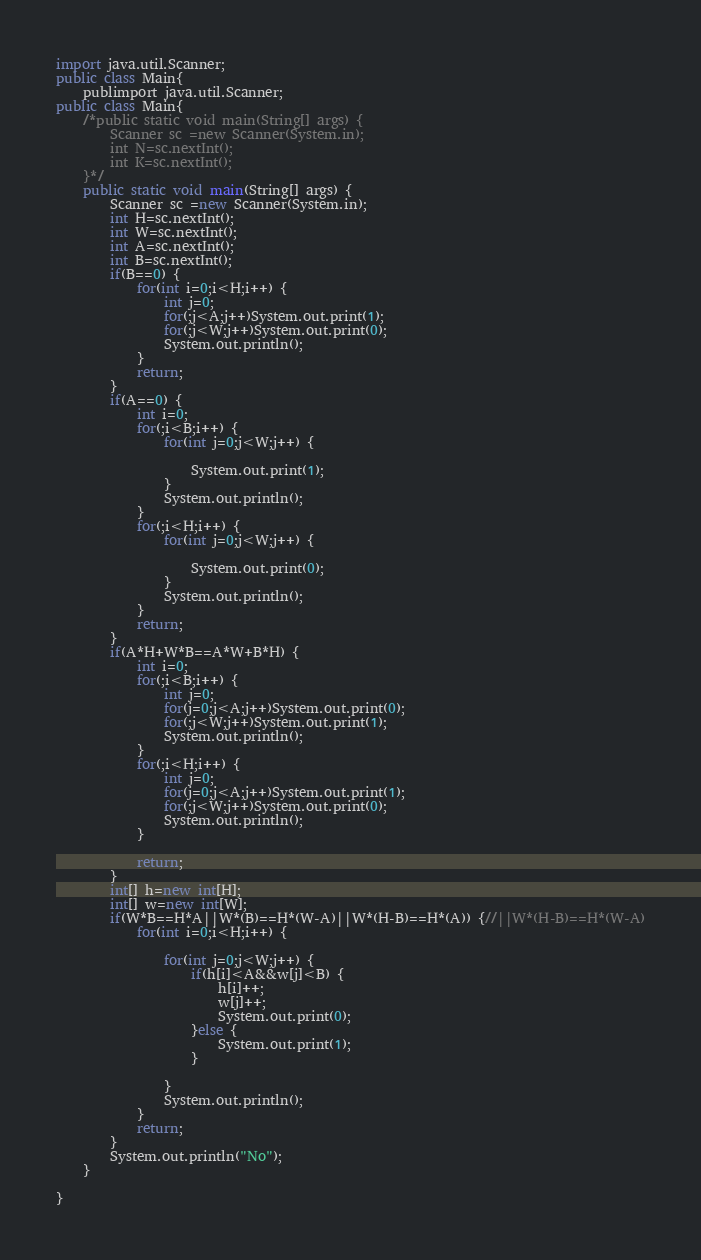Convert code to text. <code><loc_0><loc_0><loc_500><loc_500><_Java_>import java.util.Scanner;
public class Main{
	publimport java.util.Scanner;
public class Main{
	/*public static void main(String[] args) {
		Scanner sc =new Scanner(System.in);
		int N=sc.nextInt();
		int K=sc.nextInt();
	}*/
	public static void main(String[] args) {
		Scanner sc =new Scanner(System.in);
		int H=sc.nextInt();
		int W=sc.nextInt();
		int A=sc.nextInt();
		int B=sc.nextInt();
		if(B==0) {
			for(int i=0;i<H;i++) {
				int j=0;
				for(;j<A;j++)System.out.print(1);
				for(;j<W;j++)System.out.print(0);
				System.out.println();
			}
			return;
		}
		if(A==0) {
			int i=0;
			for(;i<B;i++) {
				for(int j=0;j<W;j++) {

					System.out.print(1);
				}
				System.out.println();
			}
			for(;i<H;i++) {
				for(int j=0;j<W;j++) {

					System.out.print(0);
				}
				System.out.println();
			}
			return;
		}
		if(A*H+W*B==A*W+B*H) {
			int i=0;
			for(;i<B;i++) {
				int j=0;
				for(j=0;j<A;j++)System.out.print(0);
				for(;j<W;j++)System.out.print(1);
				System.out.println();
			}
			for(;i<H;i++) {
				int j=0;
				for(j=0;j<A;j++)System.out.print(1);
				for(;j<W;j++)System.out.print(0);
				System.out.println();
			}

			return;
		}
		int[] h=new int[H];
		int[] w=new int[W];
		if(W*B==H*A||W*(B)==H*(W-A)||W*(H-B)==H*(A)) {//||W*(H-B)==H*(W-A)
			for(int i=0;i<H;i++) {

				for(int j=0;j<W;j++) {
					if(h[i]<A&&w[j]<B) {
						h[i]++;
						w[j]++;
						System.out.print(0);
					}else {
						System.out.print(1);
					}

				}
				System.out.println();
			}
			return;
		}
		System.out.println("No");
	}

}
</code> 